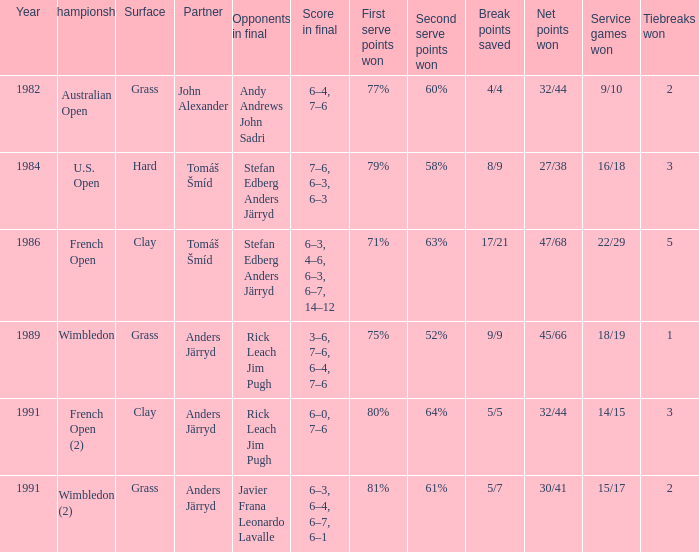What was the final score in 1986? 6–3, 4–6, 6–3, 6–7, 14–12. 